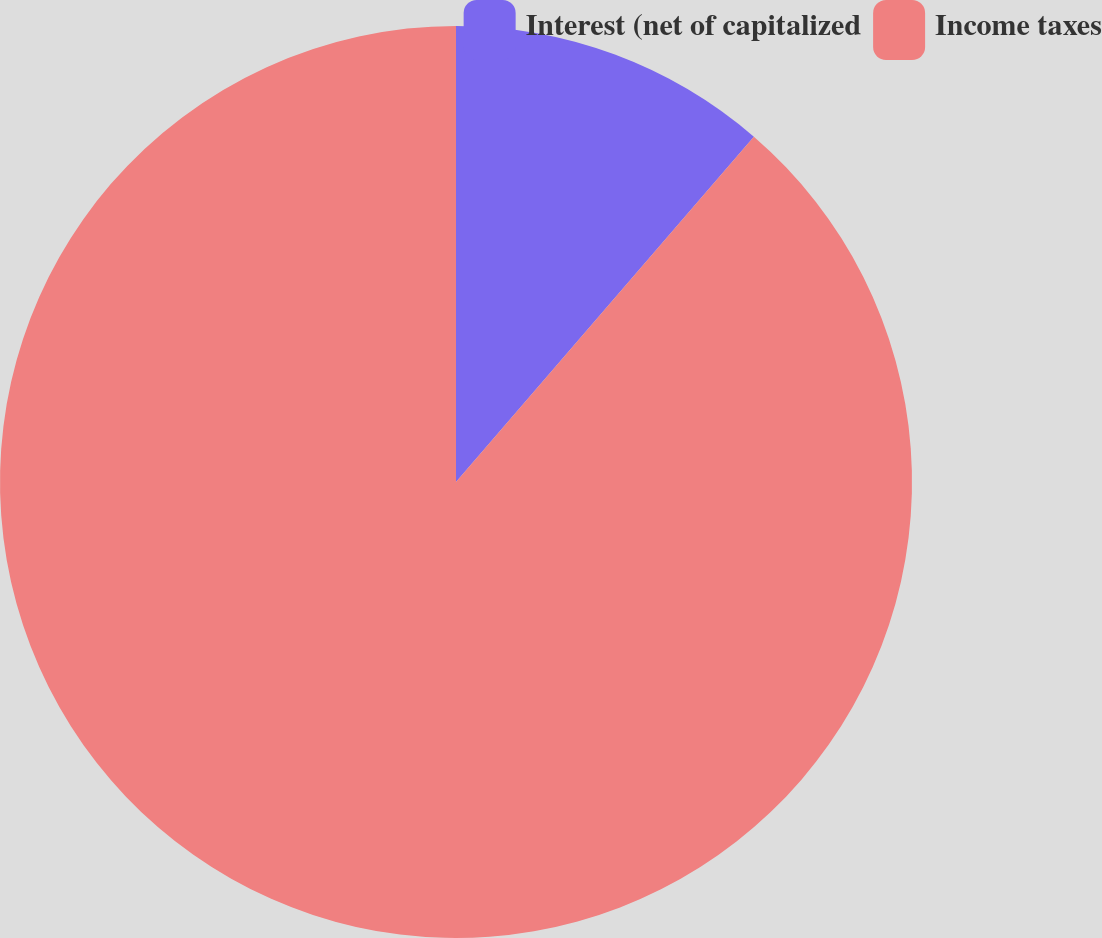Convert chart to OTSL. <chart><loc_0><loc_0><loc_500><loc_500><pie_chart><fcel>Interest (net of capitalized<fcel>Income taxes<nl><fcel>11.33%<fcel>88.67%<nl></chart> 